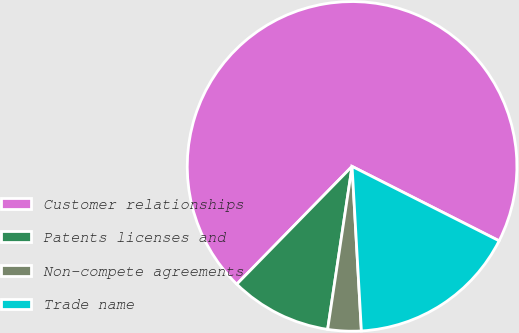Convert chart to OTSL. <chart><loc_0><loc_0><loc_500><loc_500><pie_chart><fcel>Customer relationships<fcel>Patents licenses and<fcel>Non-compete agreements<fcel>Trade name<nl><fcel>70.13%<fcel>9.96%<fcel>3.27%<fcel>16.64%<nl></chart> 